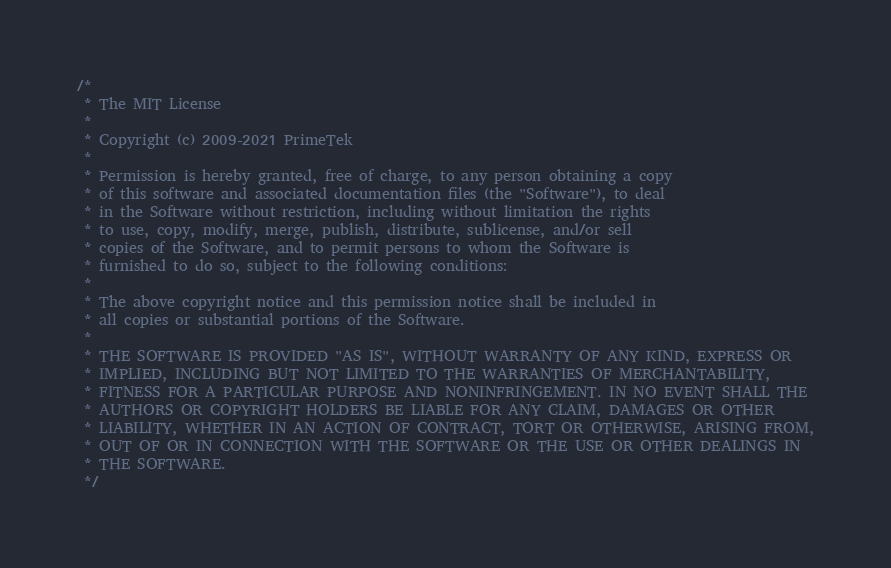<code> <loc_0><loc_0><loc_500><loc_500><_Java_>/*
 * The MIT License
 *
 * Copyright (c) 2009-2021 PrimeTek
 *
 * Permission is hereby granted, free of charge, to any person obtaining a copy
 * of this software and associated documentation files (the "Software"), to deal
 * in the Software without restriction, including without limitation the rights
 * to use, copy, modify, merge, publish, distribute, sublicense, and/or sell
 * copies of the Software, and to permit persons to whom the Software is
 * furnished to do so, subject to the following conditions:
 *
 * The above copyright notice and this permission notice shall be included in
 * all copies or substantial portions of the Software.
 *
 * THE SOFTWARE IS PROVIDED "AS IS", WITHOUT WARRANTY OF ANY KIND, EXPRESS OR
 * IMPLIED, INCLUDING BUT NOT LIMITED TO THE WARRANTIES OF MERCHANTABILITY,
 * FITNESS FOR A PARTICULAR PURPOSE AND NONINFRINGEMENT. IN NO EVENT SHALL THE
 * AUTHORS OR COPYRIGHT HOLDERS BE LIABLE FOR ANY CLAIM, DAMAGES OR OTHER
 * LIABILITY, WHETHER IN AN ACTION OF CONTRACT, TORT OR OTHERWISE, ARISING FROM,
 * OUT OF OR IN CONNECTION WITH THE SOFTWARE OR THE USE OR OTHER DEALINGS IN
 * THE SOFTWARE.
 */</code> 